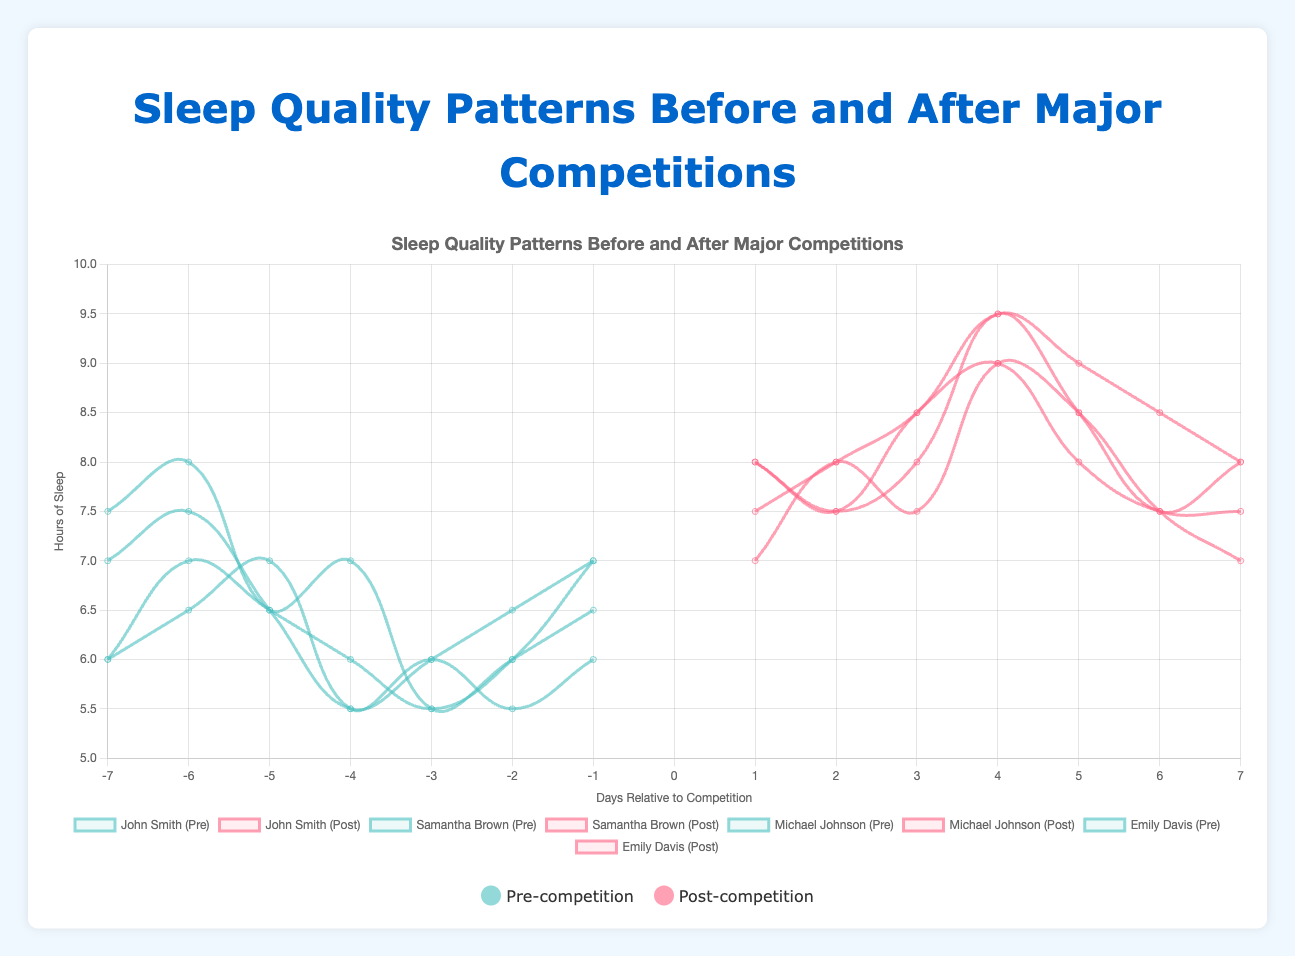How does John Smith's post-competition sleep quality compare to his pre-competition sleep quality on Day 4? On Day 4 post-competition, John Smith's sleep quality is 9 hours. Pre-competition, on Day -4, his sleep quality is 7 hours. Comparing both values, he has 2 hours more sleep post-competition.
Answer: 2 hours more What is the average post-competition sleep hours for Samantha Brown? Samantha Brown has post-competition sleep data for 7 days: 8, 7.5, 8.5, 9, 8, 7.5, and 7.5 hours. The sum of these hours is 56.5. Dividing by the number of days (7), the average sleep hours is 56.5/7 = 8.07.
Answer: 8.07 hours Who had the highest increase in sleep quality from the day before the competition to the day after the competition? To determine this, we need to calculate the difference between the sleep quality on Day 1 post-competition and Day -1 pre-competition for each athlete. John Smith: 7 - 6.5 = 0.5 Samantha Brown: 8 - 6 = 2 Michael Johnson: 7.5 - 7 = 0.5 Emily Davis: 8 - 7 = 1 Samantha Brown had the highest increase in sleep quality of 2 hours.
Answer: Samantha Brown Among the athletes, who shows the most consistent sleep hours post-competition (least variation)? To find the most consistent sleep hours, we look for the athlete with the least variation in sleep hours post-competition. By inspection: John Smith: 7, 8, 7.5, 9, 8.5, 7.5, 7 (difference range: 9-7=2) Samantha Brown: 8, 7.5, 8.5, 9, 8, 7.5, 7.5 (difference range: 9-7.5=1.5) Michael Johnson: 7.5, 8, 8.5, 9.5, 9, 8.5, 8 (difference range: 9.5-7.5=2) Emily Davis: 8, 7.5, 8, 9.5, 8.5, 7.5, 8 (difference range: 9.5-7.5=2) Samantha Brown has the least variation post-competition with a range of 1.5 hours.
Answer: Samantha Brown On which day before the competition did Emily Davis have the lowest sleep quality? Emily Davis has her lowest pre-competition sleep quality on Day -3 with 5.5 hours of sleep.
Answer: Day -3 What is the total sum of post-competition sleep hours for Michael Johnson over the 7 days? Michael Johnson's post-competition sleep hours for 7 days are: 7.5, 8, 8.5, 9.5, 9, 8.5, 8. The sum is 7.5 + 8 + 8.5 + 9.5 + 9 + 8.5 + 8 = 59.
Answer: 59 hours 